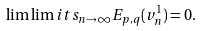<formula> <loc_0><loc_0><loc_500><loc_500>\lim \lim i t s _ { n \rightarrow \infty } E _ { p , q } ( v _ { n } ^ { 1 } ) = 0 .</formula> 